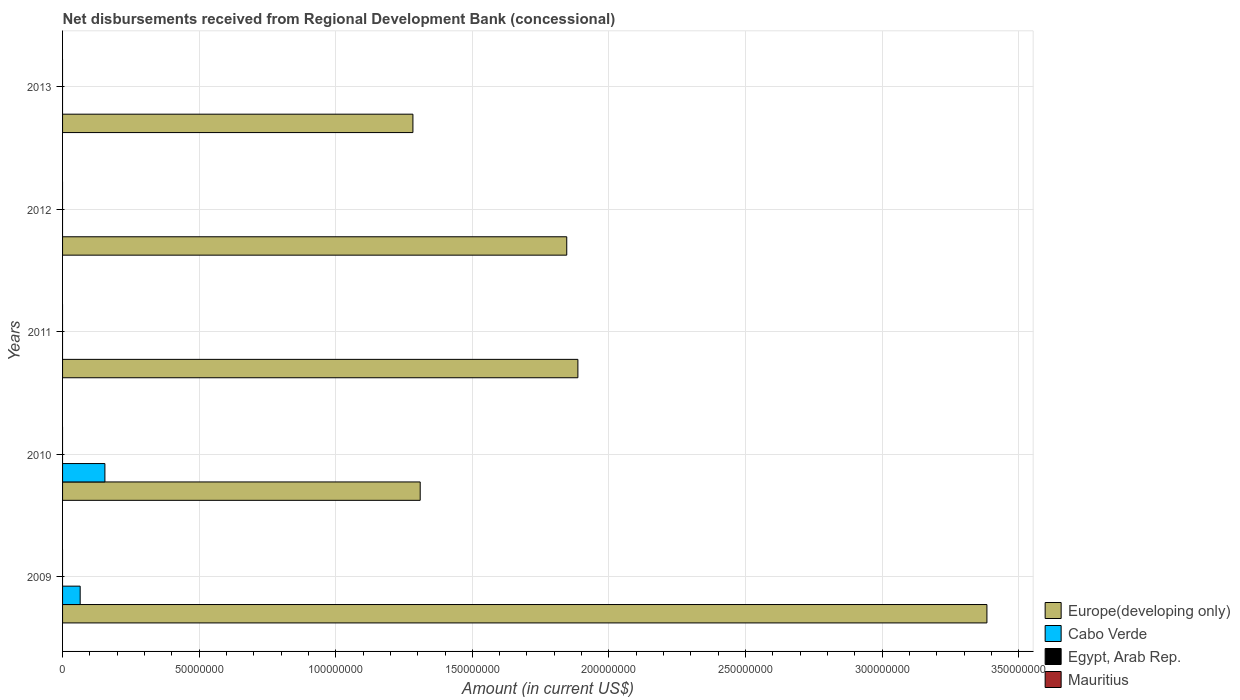How many different coloured bars are there?
Your answer should be compact. 2. Are the number of bars per tick equal to the number of legend labels?
Ensure brevity in your answer.  No. Are the number of bars on each tick of the Y-axis equal?
Provide a short and direct response. No. How many bars are there on the 2nd tick from the bottom?
Your response must be concise. 2. What is the label of the 1st group of bars from the top?
Provide a succinct answer. 2013. In how many cases, is the number of bars for a given year not equal to the number of legend labels?
Ensure brevity in your answer.  5. What is the amount of disbursements received from Regional Development Bank in Europe(developing only) in 2009?
Your answer should be compact. 3.38e+08. Across all years, what is the maximum amount of disbursements received from Regional Development Bank in Europe(developing only)?
Ensure brevity in your answer.  3.38e+08. Across all years, what is the minimum amount of disbursements received from Regional Development Bank in Egypt, Arab Rep.?
Offer a very short reply. 0. What is the total amount of disbursements received from Regional Development Bank in Cabo Verde in the graph?
Provide a short and direct response. 2.19e+07. What is the difference between the amount of disbursements received from Regional Development Bank in Europe(developing only) in 2011 and that in 2013?
Your answer should be compact. 6.04e+07. What is the difference between the amount of disbursements received from Regional Development Bank in Egypt, Arab Rep. in 2010 and the amount of disbursements received from Regional Development Bank in Cabo Verde in 2012?
Your answer should be very brief. 0. What is the average amount of disbursements received from Regional Development Bank in Cabo Verde per year?
Ensure brevity in your answer.  4.39e+06. In the year 2009, what is the difference between the amount of disbursements received from Regional Development Bank in Cabo Verde and amount of disbursements received from Regional Development Bank in Europe(developing only)?
Provide a succinct answer. -3.32e+08. In how many years, is the amount of disbursements received from Regional Development Bank in Egypt, Arab Rep. greater than 100000000 US$?
Provide a short and direct response. 0. What is the ratio of the amount of disbursements received from Regional Development Bank in Europe(developing only) in 2011 to that in 2012?
Your answer should be compact. 1.02. Is the amount of disbursements received from Regional Development Bank in Europe(developing only) in 2010 less than that in 2012?
Offer a terse response. Yes. What is the difference between the highest and the lowest amount of disbursements received from Regional Development Bank in Cabo Verde?
Give a very brief answer. 1.55e+07. In how many years, is the amount of disbursements received from Regional Development Bank in Europe(developing only) greater than the average amount of disbursements received from Regional Development Bank in Europe(developing only) taken over all years?
Give a very brief answer. 1. Is it the case that in every year, the sum of the amount of disbursements received from Regional Development Bank in Cabo Verde and amount of disbursements received from Regional Development Bank in Egypt, Arab Rep. is greater than the sum of amount of disbursements received from Regional Development Bank in Mauritius and amount of disbursements received from Regional Development Bank in Europe(developing only)?
Your answer should be compact. No. Are all the bars in the graph horizontal?
Give a very brief answer. Yes. Are the values on the major ticks of X-axis written in scientific E-notation?
Your response must be concise. No. Does the graph contain any zero values?
Provide a short and direct response. Yes. Does the graph contain grids?
Provide a succinct answer. Yes. What is the title of the graph?
Your response must be concise. Net disbursements received from Regional Development Bank (concessional). Does "Qatar" appear as one of the legend labels in the graph?
Offer a very short reply. No. What is the Amount (in current US$) in Europe(developing only) in 2009?
Your answer should be compact. 3.38e+08. What is the Amount (in current US$) in Cabo Verde in 2009?
Give a very brief answer. 6.44e+06. What is the Amount (in current US$) of Mauritius in 2009?
Ensure brevity in your answer.  0. What is the Amount (in current US$) of Europe(developing only) in 2010?
Ensure brevity in your answer.  1.31e+08. What is the Amount (in current US$) in Cabo Verde in 2010?
Give a very brief answer. 1.55e+07. What is the Amount (in current US$) of Egypt, Arab Rep. in 2010?
Your answer should be compact. 0. What is the Amount (in current US$) in Mauritius in 2010?
Make the answer very short. 0. What is the Amount (in current US$) in Europe(developing only) in 2011?
Your response must be concise. 1.89e+08. What is the Amount (in current US$) of Cabo Verde in 2011?
Your answer should be very brief. 0. What is the Amount (in current US$) in Egypt, Arab Rep. in 2011?
Provide a short and direct response. 0. What is the Amount (in current US$) in Europe(developing only) in 2012?
Your answer should be very brief. 1.85e+08. What is the Amount (in current US$) of Europe(developing only) in 2013?
Your answer should be very brief. 1.28e+08. Across all years, what is the maximum Amount (in current US$) of Europe(developing only)?
Ensure brevity in your answer.  3.38e+08. Across all years, what is the maximum Amount (in current US$) of Cabo Verde?
Offer a very short reply. 1.55e+07. Across all years, what is the minimum Amount (in current US$) in Europe(developing only)?
Your answer should be compact. 1.28e+08. Across all years, what is the minimum Amount (in current US$) in Cabo Verde?
Offer a very short reply. 0. What is the total Amount (in current US$) of Europe(developing only) in the graph?
Offer a very short reply. 9.71e+08. What is the total Amount (in current US$) in Cabo Verde in the graph?
Provide a succinct answer. 2.19e+07. What is the total Amount (in current US$) in Mauritius in the graph?
Offer a terse response. 0. What is the difference between the Amount (in current US$) of Europe(developing only) in 2009 and that in 2010?
Offer a very short reply. 2.07e+08. What is the difference between the Amount (in current US$) in Cabo Verde in 2009 and that in 2010?
Offer a very short reply. -9.06e+06. What is the difference between the Amount (in current US$) in Europe(developing only) in 2009 and that in 2011?
Give a very brief answer. 1.50e+08. What is the difference between the Amount (in current US$) in Europe(developing only) in 2009 and that in 2012?
Provide a short and direct response. 1.54e+08. What is the difference between the Amount (in current US$) of Europe(developing only) in 2009 and that in 2013?
Keep it short and to the point. 2.10e+08. What is the difference between the Amount (in current US$) of Europe(developing only) in 2010 and that in 2011?
Provide a short and direct response. -5.77e+07. What is the difference between the Amount (in current US$) of Europe(developing only) in 2010 and that in 2012?
Provide a short and direct response. -5.36e+07. What is the difference between the Amount (in current US$) in Europe(developing only) in 2010 and that in 2013?
Offer a terse response. 2.67e+06. What is the difference between the Amount (in current US$) in Europe(developing only) in 2011 and that in 2012?
Keep it short and to the point. 4.08e+06. What is the difference between the Amount (in current US$) of Europe(developing only) in 2011 and that in 2013?
Offer a very short reply. 6.04e+07. What is the difference between the Amount (in current US$) in Europe(developing only) in 2012 and that in 2013?
Give a very brief answer. 5.63e+07. What is the difference between the Amount (in current US$) of Europe(developing only) in 2009 and the Amount (in current US$) of Cabo Verde in 2010?
Offer a terse response. 3.23e+08. What is the average Amount (in current US$) in Europe(developing only) per year?
Make the answer very short. 1.94e+08. What is the average Amount (in current US$) in Cabo Verde per year?
Keep it short and to the point. 4.39e+06. In the year 2009, what is the difference between the Amount (in current US$) of Europe(developing only) and Amount (in current US$) of Cabo Verde?
Your answer should be compact. 3.32e+08. In the year 2010, what is the difference between the Amount (in current US$) of Europe(developing only) and Amount (in current US$) of Cabo Verde?
Provide a succinct answer. 1.15e+08. What is the ratio of the Amount (in current US$) in Europe(developing only) in 2009 to that in 2010?
Offer a terse response. 2.58. What is the ratio of the Amount (in current US$) in Cabo Verde in 2009 to that in 2010?
Your response must be concise. 0.42. What is the ratio of the Amount (in current US$) in Europe(developing only) in 2009 to that in 2011?
Provide a succinct answer. 1.79. What is the ratio of the Amount (in current US$) in Europe(developing only) in 2009 to that in 2012?
Give a very brief answer. 1.83. What is the ratio of the Amount (in current US$) in Europe(developing only) in 2009 to that in 2013?
Give a very brief answer. 2.64. What is the ratio of the Amount (in current US$) in Europe(developing only) in 2010 to that in 2011?
Ensure brevity in your answer.  0.69. What is the ratio of the Amount (in current US$) of Europe(developing only) in 2010 to that in 2012?
Offer a terse response. 0.71. What is the ratio of the Amount (in current US$) of Europe(developing only) in 2010 to that in 2013?
Your answer should be very brief. 1.02. What is the ratio of the Amount (in current US$) of Europe(developing only) in 2011 to that in 2012?
Offer a terse response. 1.02. What is the ratio of the Amount (in current US$) in Europe(developing only) in 2011 to that in 2013?
Your answer should be compact. 1.47. What is the ratio of the Amount (in current US$) in Europe(developing only) in 2012 to that in 2013?
Your answer should be compact. 1.44. What is the difference between the highest and the second highest Amount (in current US$) in Europe(developing only)?
Make the answer very short. 1.50e+08. What is the difference between the highest and the lowest Amount (in current US$) in Europe(developing only)?
Provide a short and direct response. 2.10e+08. What is the difference between the highest and the lowest Amount (in current US$) of Cabo Verde?
Give a very brief answer. 1.55e+07. 